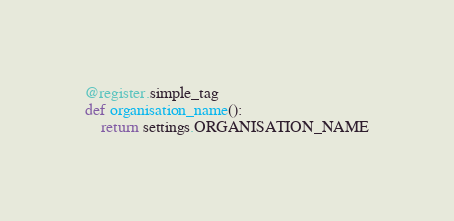<code> <loc_0><loc_0><loc_500><loc_500><_Python_>@register.simple_tag
def organisation_name():
    return settings.ORGANISATION_NAME
</code> 